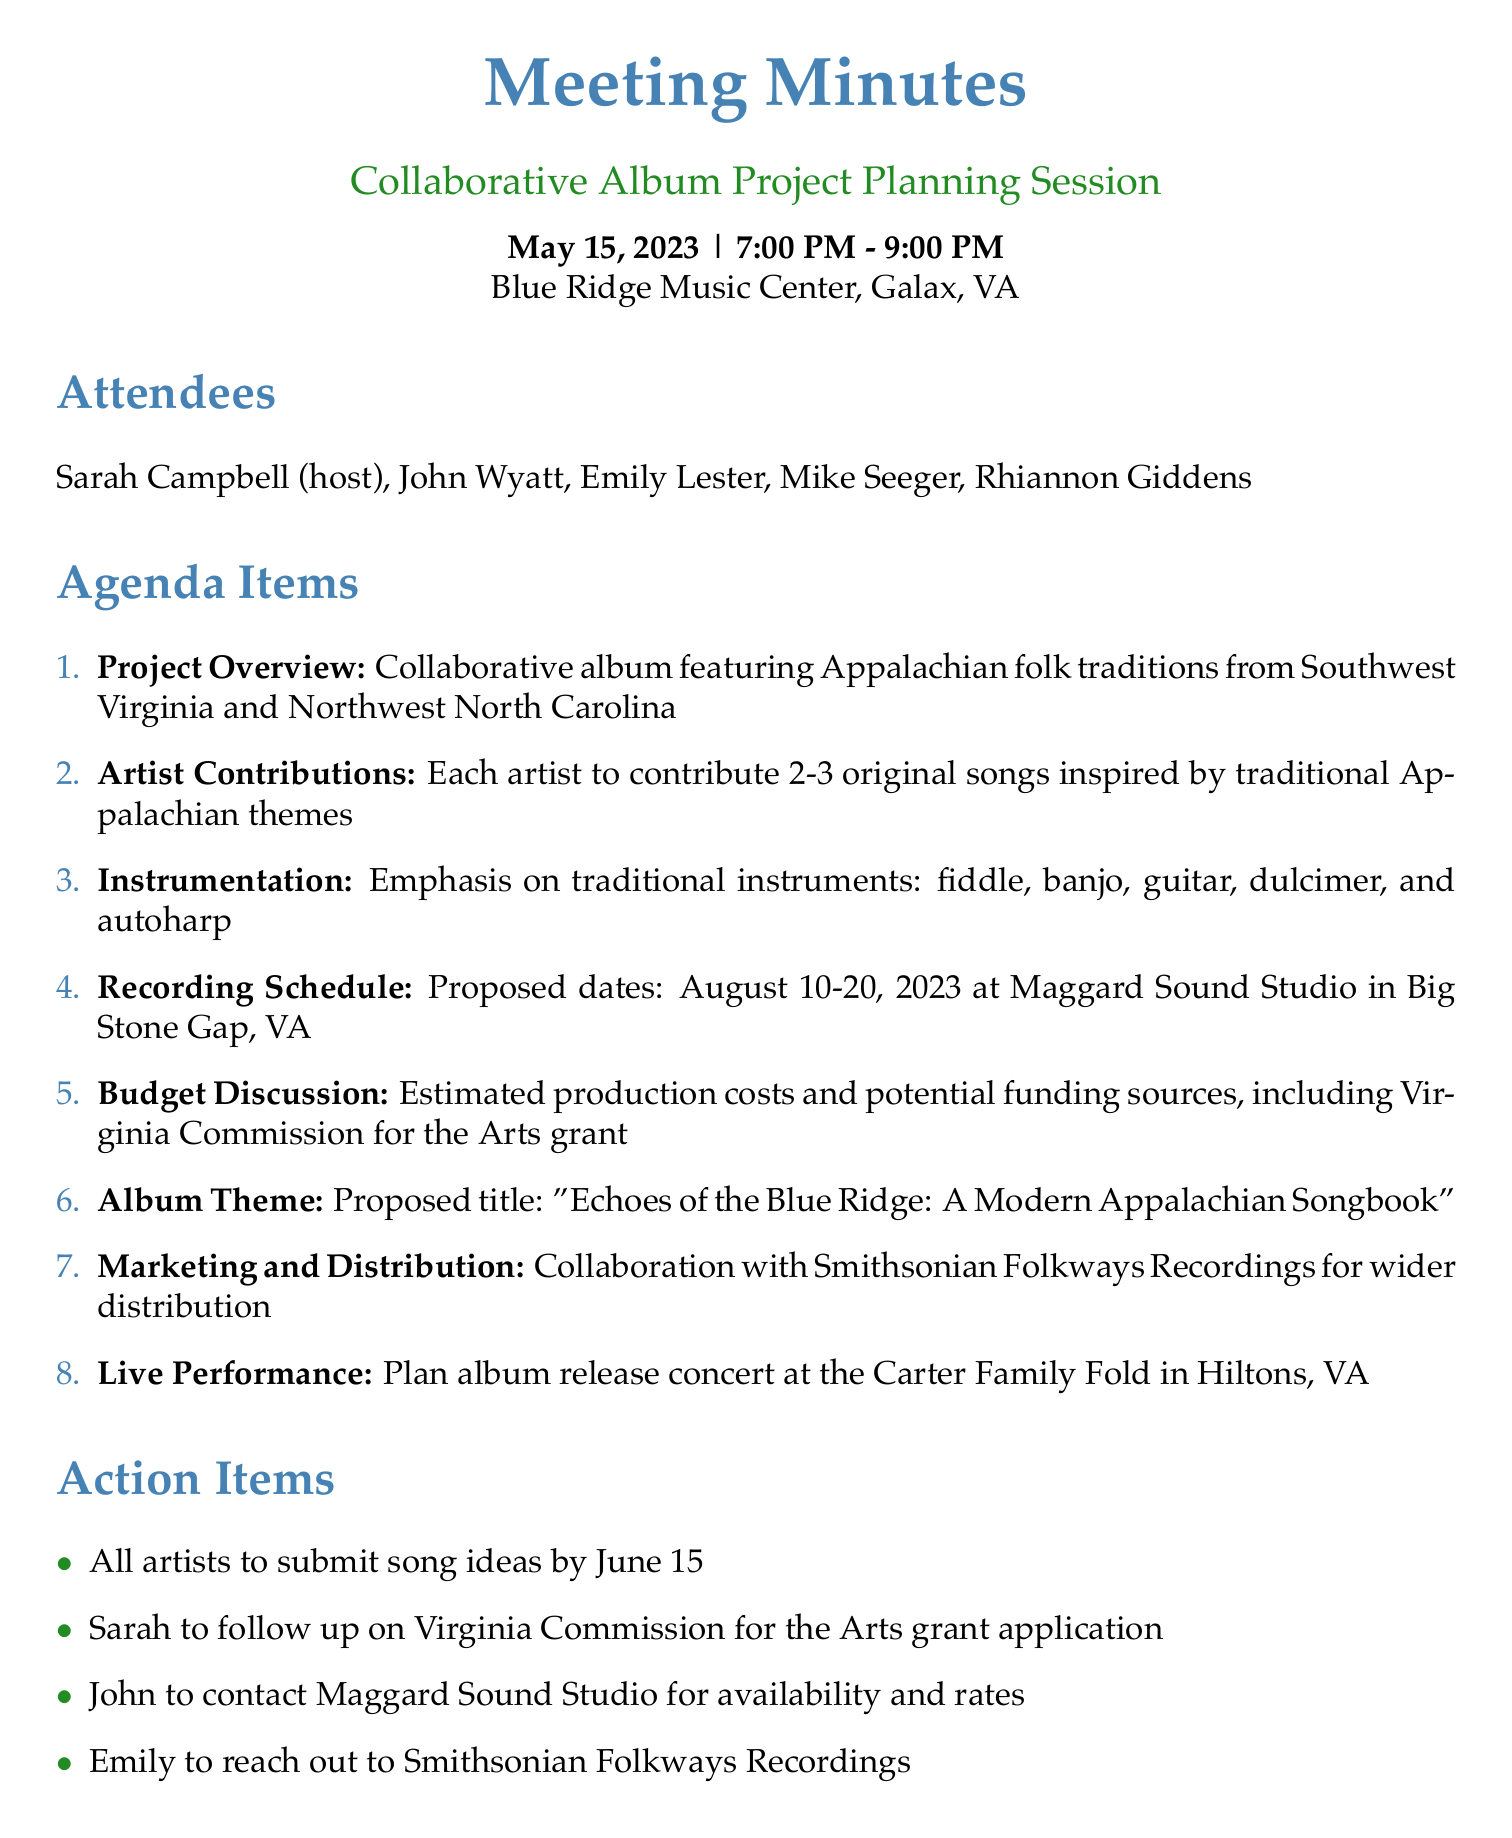What is the date of the meeting? The date of the meeting is specified in the document as May 15, 2023.
Answer: May 15, 2023 Who hosted the meeting? The host of the meeting is identified as Sarah Campbell in the attendees section.
Answer: Sarah Campbell What is the proposed title of the album? The proposed album title is mentioned under the Agenda Items section.
Answer: Echoes of the Blue Ridge: A Modern Appalachian Songbook When is the deadline for submitting song ideas? The deadline for submitting song ideas is noted in the action items of the document.
Answer: June 15 What is the primary focus of the collaborative album? The focus of the collaborative album is outlined in the project overview section of the document.
Answer: Appalachian folk traditions from Southwest Virginia and Northwest North Carolina How many original songs is each artist expected to contribute? The expected number of original songs each artist is to contribute is mentioned in the artist contributions agenda item.
Answer: 2-3 Where is the album release concert planned? The location for the album release concert can be found under the live performance agenda item.
Answer: Carter Family Fold in Hiltons, VA Who will follow up on the Virginia Commission for the Arts grant application? The action item specifies that Sarah will follow up on the grant application.
Answer: Sarah 